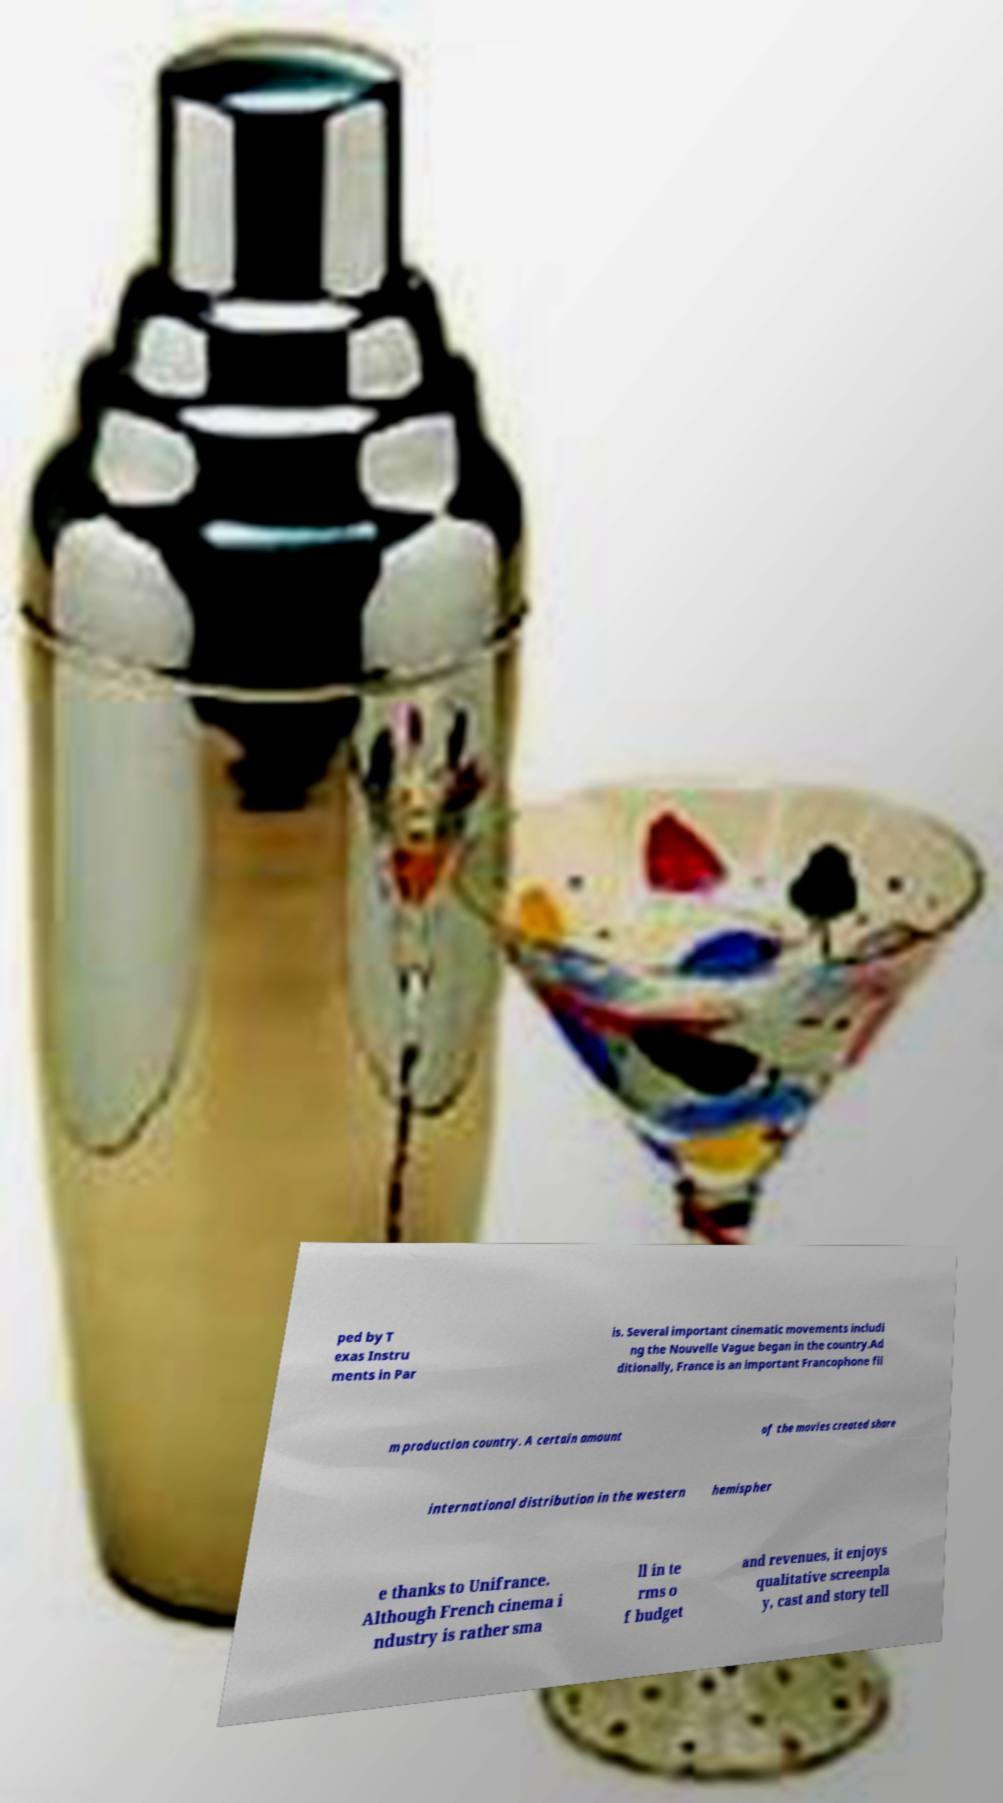Could you assist in decoding the text presented in this image and type it out clearly? ped by T exas Instru ments in Par is. Several important cinematic movements includi ng the Nouvelle Vague began in the country.Ad ditionally, France is an important Francophone fil m production country. A certain amount of the movies created share international distribution in the western hemispher e thanks to Unifrance. Although French cinema i ndustry is rather sma ll in te rms o f budget and revenues, it enjoys qualitative screenpla y, cast and story tell 